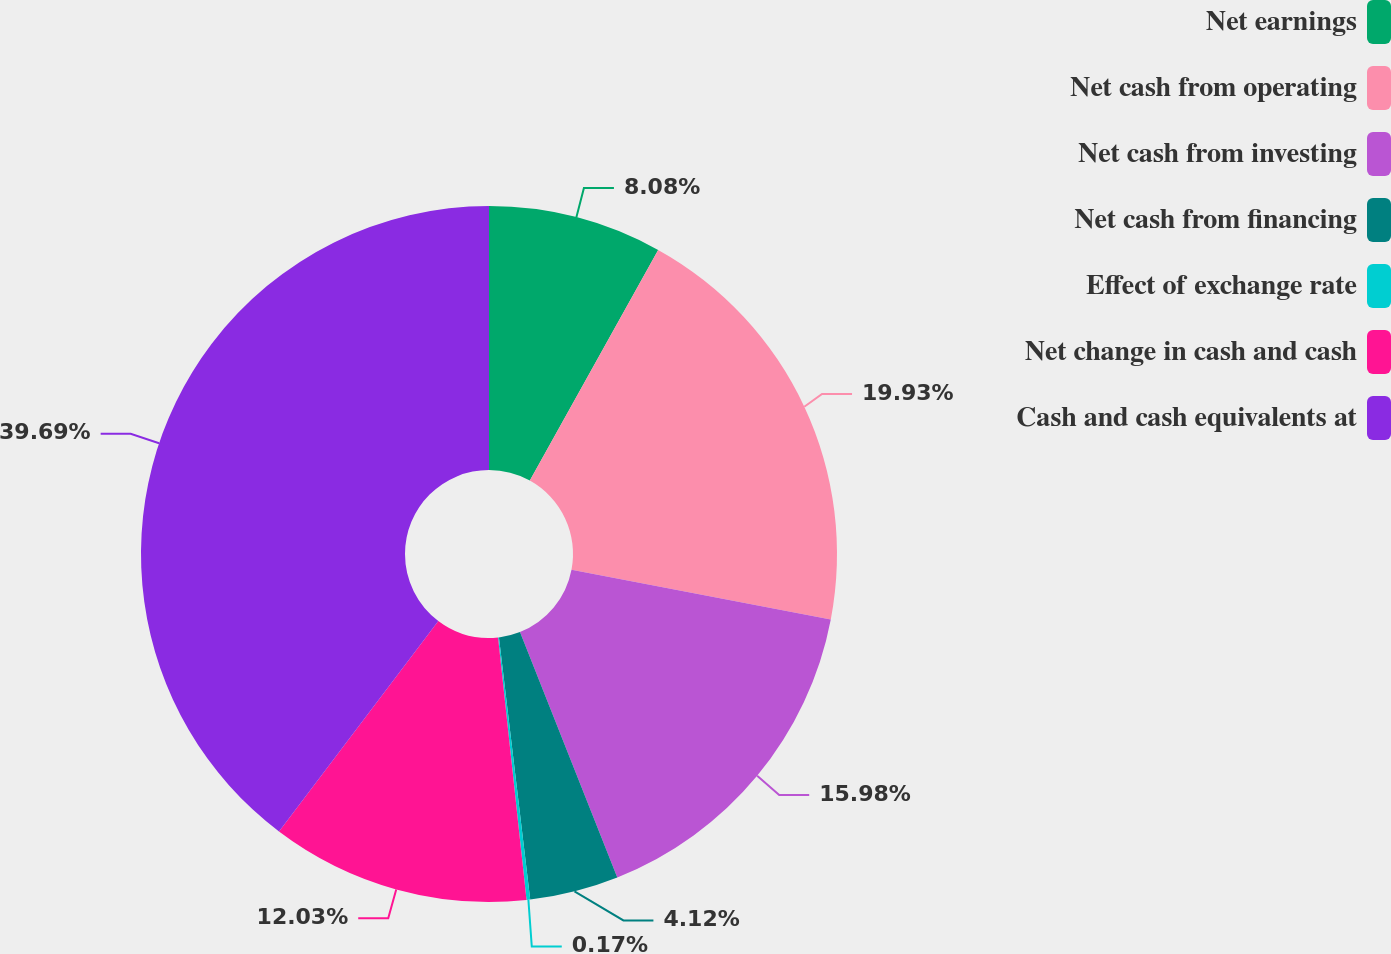Convert chart to OTSL. <chart><loc_0><loc_0><loc_500><loc_500><pie_chart><fcel>Net earnings<fcel>Net cash from operating<fcel>Net cash from investing<fcel>Net cash from financing<fcel>Effect of exchange rate<fcel>Net change in cash and cash<fcel>Cash and cash equivalents at<nl><fcel>8.08%<fcel>19.93%<fcel>15.98%<fcel>4.12%<fcel>0.17%<fcel>12.03%<fcel>39.69%<nl></chart> 